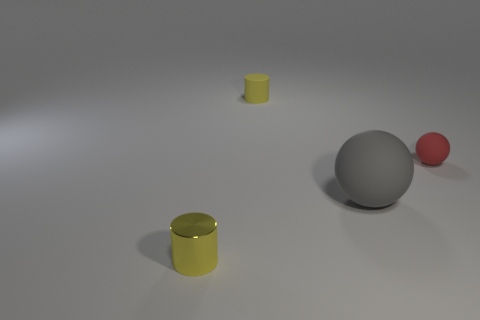Add 1 small yellow shiny things. How many objects exist? 5 Add 4 large objects. How many large objects exist? 5 Subtract 0 cyan spheres. How many objects are left? 4 Subtract all green matte cylinders. Subtract all large spheres. How many objects are left? 3 Add 4 yellow shiny objects. How many yellow shiny objects are left? 5 